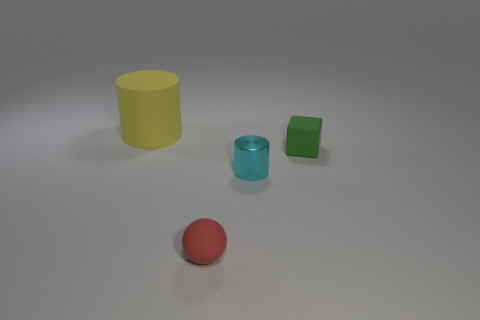Add 4 yellow cylinders. How many objects exist? 8 Subtract all balls. How many objects are left? 3 Subtract all brown balls. How many gray cylinders are left? 0 Subtract all tiny matte blocks. Subtract all blue cylinders. How many objects are left? 3 Add 1 small blocks. How many small blocks are left? 2 Add 1 metallic cylinders. How many metallic cylinders exist? 2 Subtract 0 gray cubes. How many objects are left? 4 Subtract 1 cubes. How many cubes are left? 0 Subtract all blue cylinders. Subtract all blue blocks. How many cylinders are left? 2 